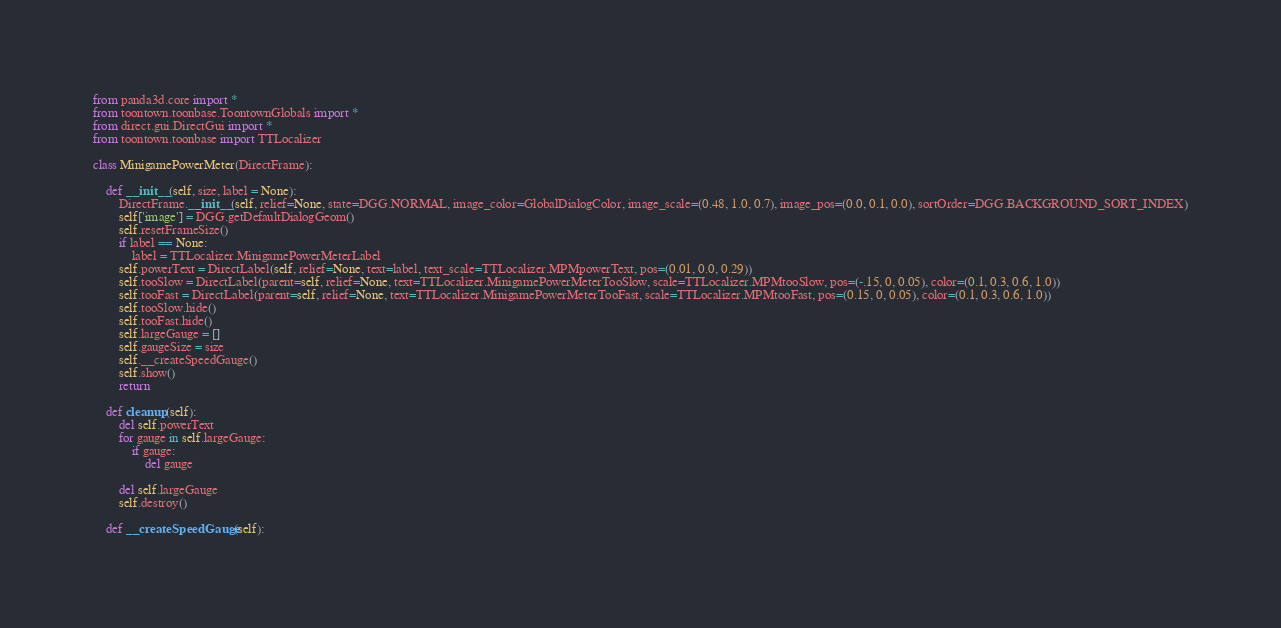<code> <loc_0><loc_0><loc_500><loc_500><_Python_>from panda3d.core import *
from toontown.toonbase.ToontownGlobals import *
from direct.gui.DirectGui import *
from toontown.toonbase import TTLocalizer

class MinigamePowerMeter(DirectFrame):

    def __init__(self, size, label = None):
        DirectFrame.__init__(self, relief=None, state=DGG.NORMAL, image_color=GlobalDialogColor, image_scale=(0.48, 1.0, 0.7), image_pos=(0.0, 0.1, 0.0), sortOrder=DGG.BACKGROUND_SORT_INDEX)
        self['image'] = DGG.getDefaultDialogGeom()
        self.resetFrameSize()
        if label == None:
            label = TTLocalizer.MinigamePowerMeterLabel
        self.powerText = DirectLabel(self, relief=None, text=label, text_scale=TTLocalizer.MPMpowerText, pos=(0.01, 0.0, 0.29))
        self.tooSlow = DirectLabel(parent=self, relief=None, text=TTLocalizer.MinigamePowerMeterTooSlow, scale=TTLocalizer.MPMtooSlow, pos=(-.15, 0, 0.05), color=(0.1, 0.3, 0.6, 1.0))
        self.tooFast = DirectLabel(parent=self, relief=None, text=TTLocalizer.MinigamePowerMeterTooFast, scale=TTLocalizer.MPMtooFast, pos=(0.15, 0, 0.05), color=(0.1, 0.3, 0.6, 1.0))
        self.tooSlow.hide()
        self.tooFast.hide()
        self.largeGauge = []
        self.gaugeSize = size
        self.__createSpeedGauge()
        self.show()
        return

    def cleanup(self):
        del self.powerText
        for gauge in self.largeGauge:
            if gauge:
                del gauge

        del self.largeGauge
        self.destroy()

    def __createSpeedGauge(self):</code> 